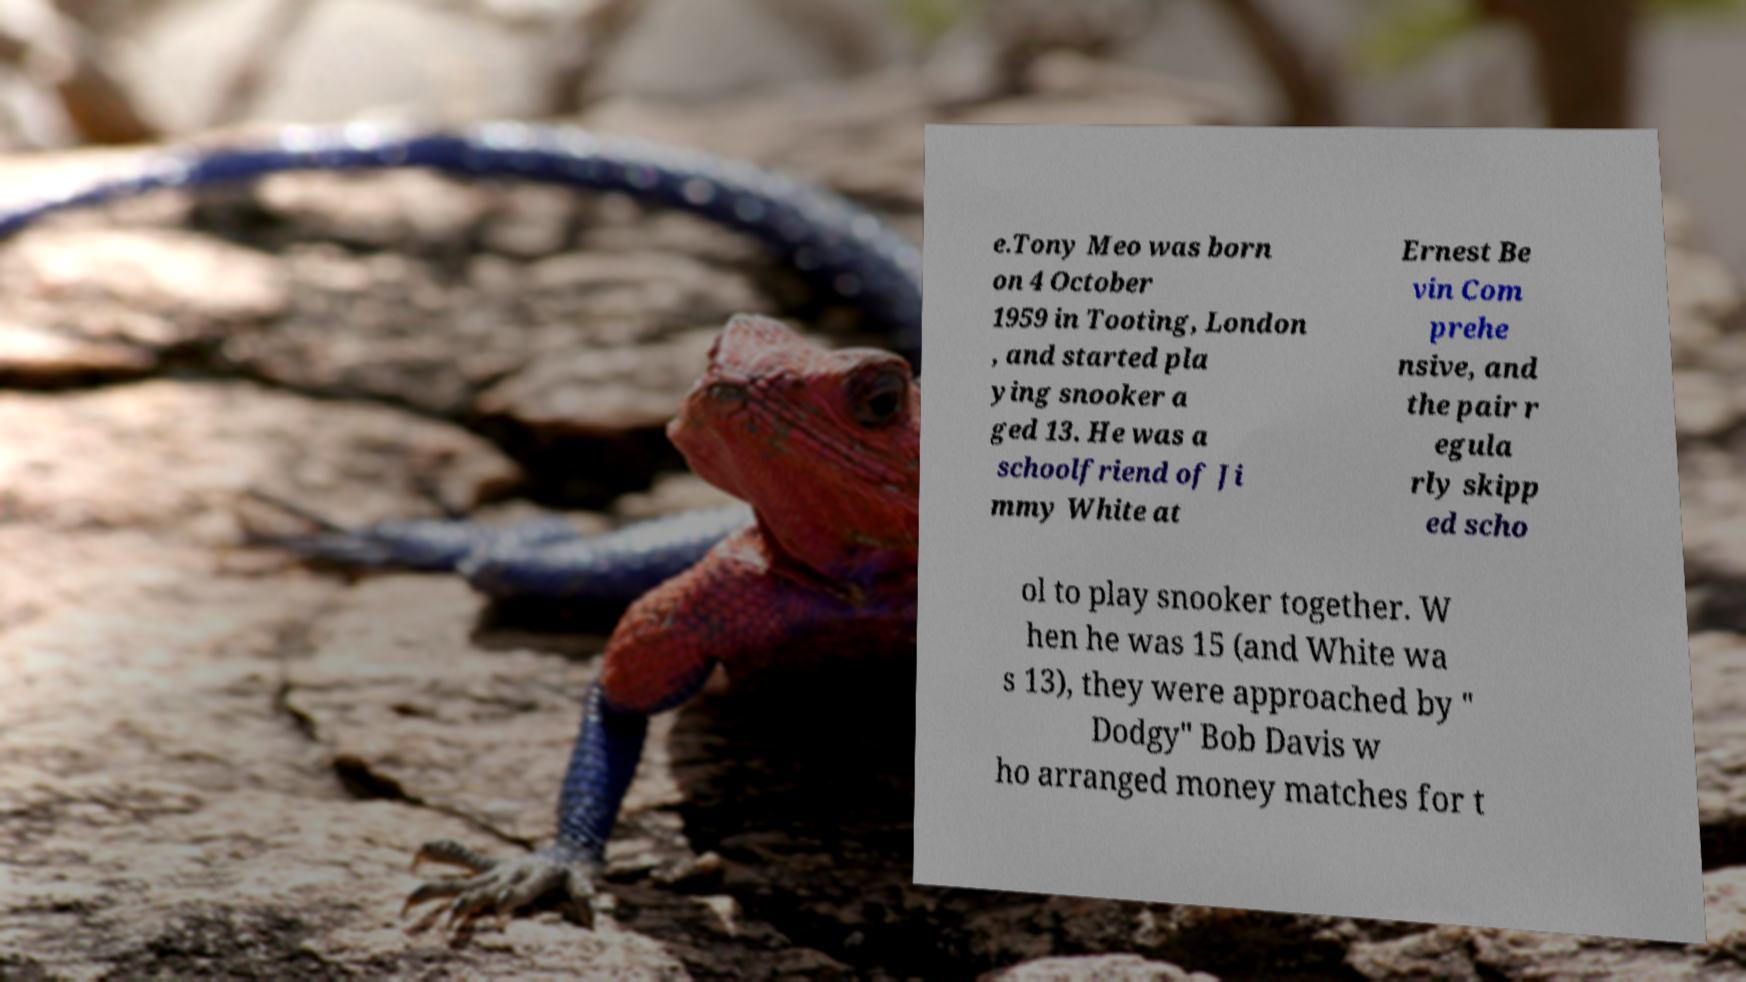Could you assist in decoding the text presented in this image and type it out clearly? e.Tony Meo was born on 4 October 1959 in Tooting, London , and started pla ying snooker a ged 13. He was a schoolfriend of Ji mmy White at Ernest Be vin Com prehe nsive, and the pair r egula rly skipp ed scho ol to play snooker together. W hen he was 15 (and White wa s 13), they were approached by " Dodgy" Bob Davis w ho arranged money matches for t 